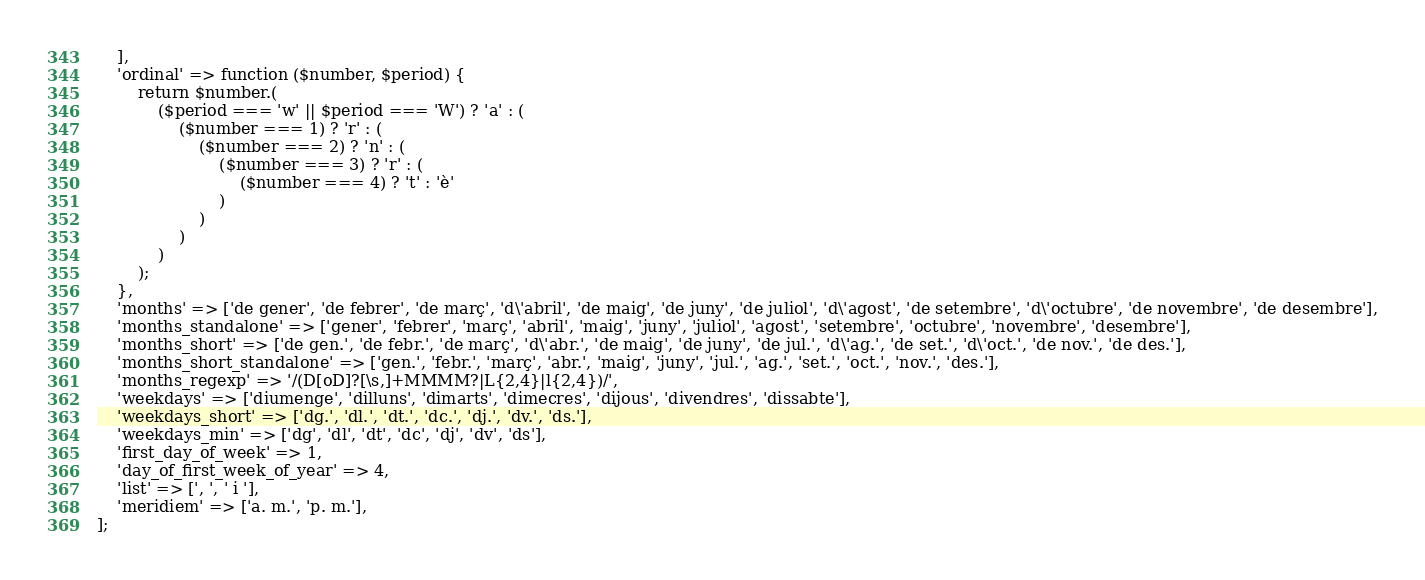<code> <loc_0><loc_0><loc_500><loc_500><_PHP_>    ],
    'ordinal' => function ($number, $period) {
        return $number.(
            ($period === 'w' || $period === 'W') ? 'a' : (
                ($number === 1) ? 'r' : (
                    ($number === 2) ? 'n' : (
                        ($number === 3) ? 'r' : (
                            ($number === 4) ? 't' : 'è'
                        )
                    )
                )
            )
        );
    },
    'months' => ['de gener', 'de febrer', 'de març', 'd\'abril', 'de maig', 'de juny', 'de juliol', 'd\'agost', 'de setembre', 'd\'octubre', 'de novembre', 'de desembre'],
    'months_standalone' => ['gener', 'febrer', 'març', 'abril', 'maig', 'juny', 'juliol', 'agost', 'setembre', 'octubre', 'novembre', 'desembre'],
    'months_short' => ['de gen.', 'de febr.', 'de març', 'd\'abr.', 'de maig', 'de juny', 'de jul.', 'd\'ag.', 'de set.', 'd\'oct.', 'de nov.', 'de des.'],
    'months_short_standalone' => ['gen.', 'febr.', 'març', 'abr.', 'maig', 'juny', 'jul.', 'ag.', 'set.', 'oct.', 'nov.', 'des.'],
    'months_regexp' => '/(D[oD]?[\s,]+MMMM?|L{2,4}|l{2,4})/',
    'weekdays' => ['diumenge', 'dilluns', 'dimarts', 'dimecres', 'dijous', 'divendres', 'dissabte'],
    'weekdays_short' => ['dg.', 'dl.', 'dt.', 'dc.', 'dj.', 'dv.', 'ds.'],
    'weekdays_min' => ['dg', 'dl', 'dt', 'dc', 'dj', 'dv', 'ds'],
    'first_day_of_week' => 1,
    'day_of_first_week_of_year' => 4,
    'list' => [', ', ' i '],
    'meridiem' => ['a. m.', 'p. m.'],
];
</code> 